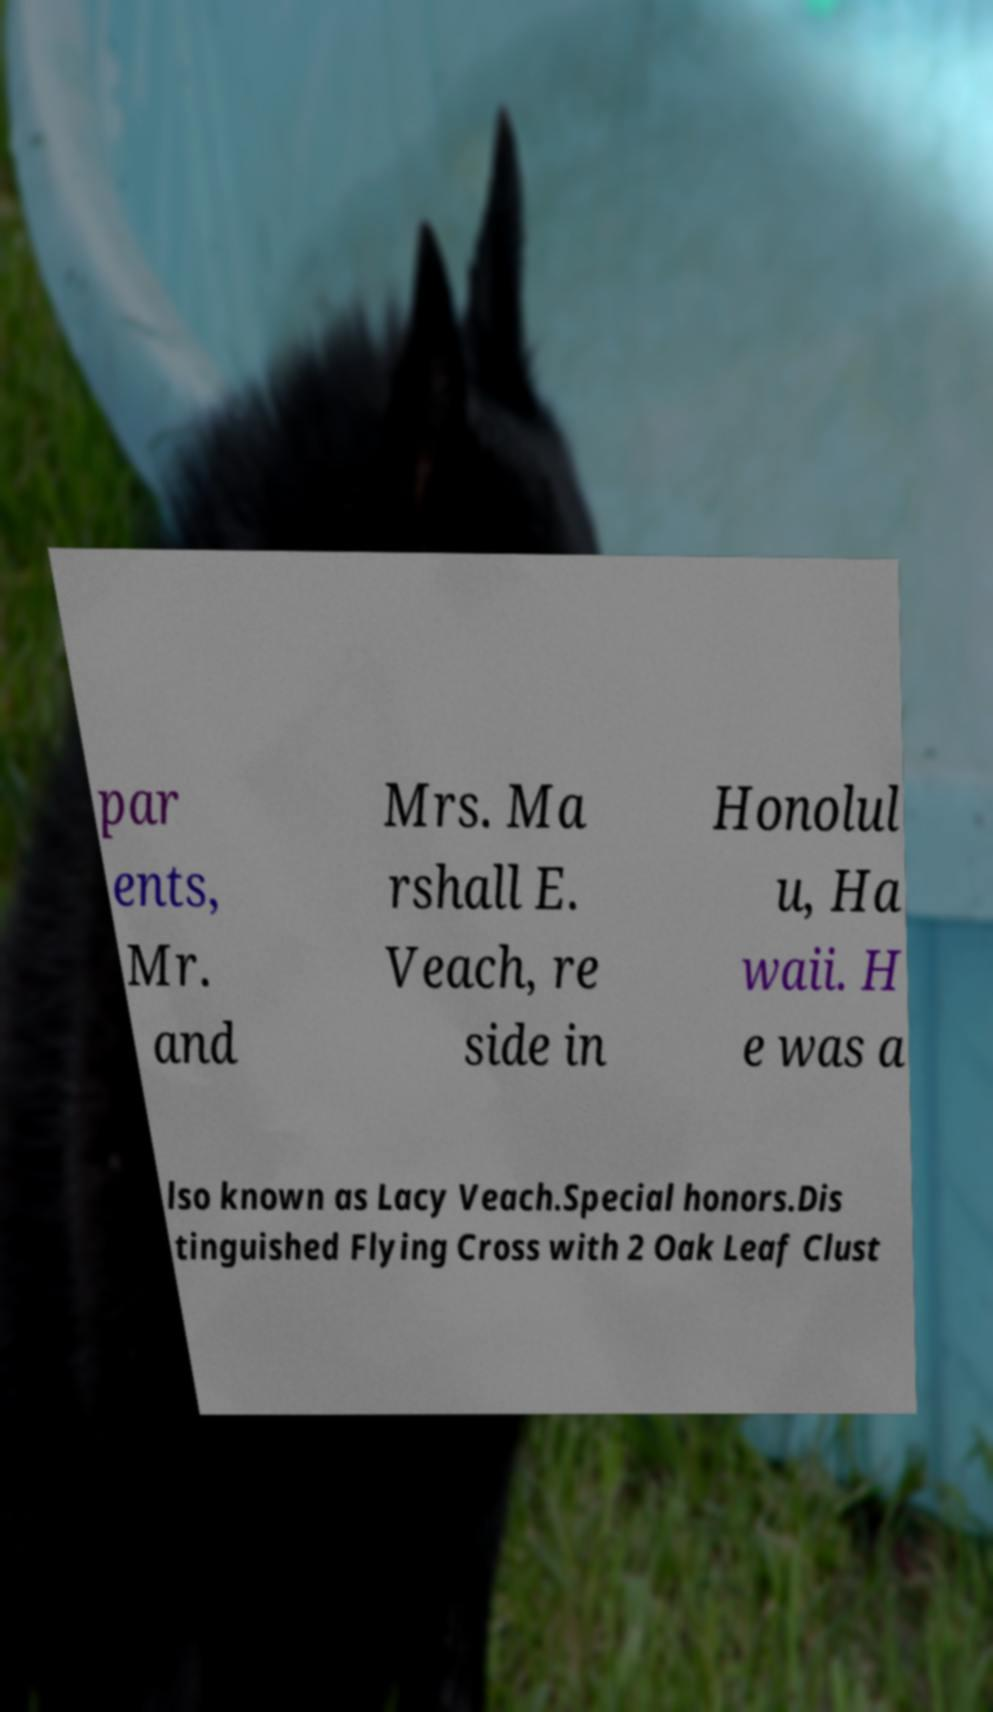What messages or text are displayed in this image? I need them in a readable, typed format. par ents, Mr. and Mrs. Ma rshall E. Veach, re side in Honolul u, Ha waii. H e was a lso known as Lacy Veach.Special honors.Dis tinguished Flying Cross with 2 Oak Leaf Clust 